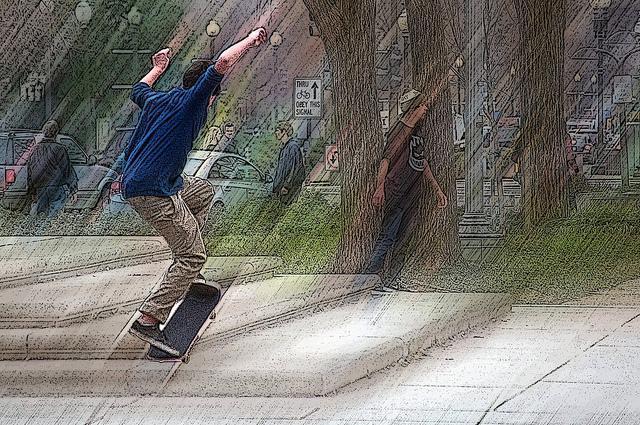World Skate is highest governing body of which game?
From the following four choices, select the correct answer to address the question.
Options: Swimming, kiting, skateboarding, surfing. Skateboarding. 